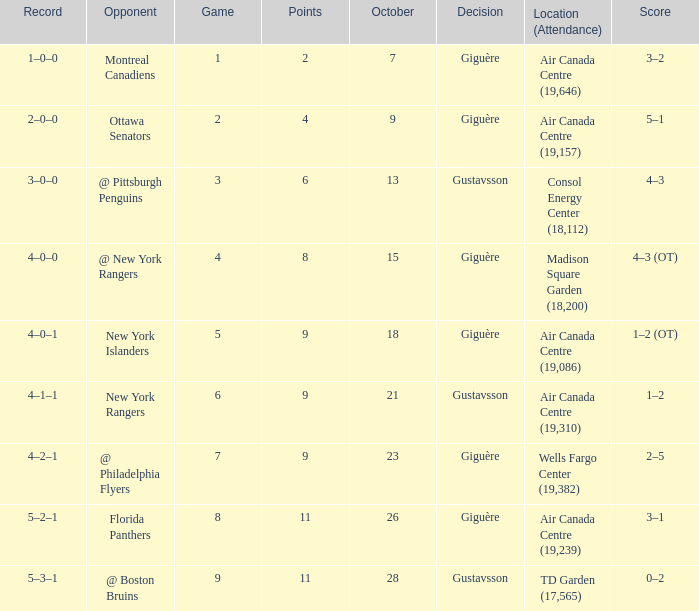What was the score for the opponent florida panthers? 1.0. 